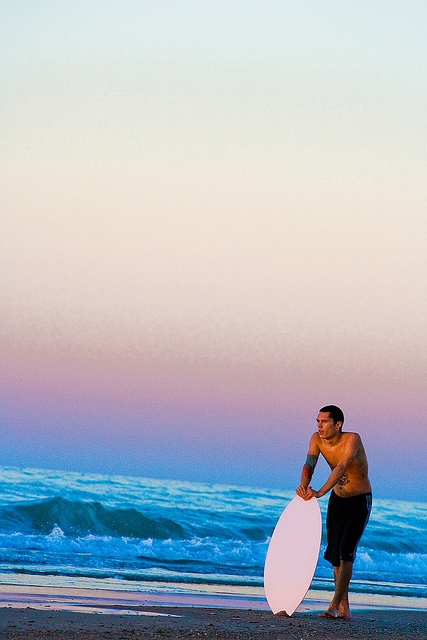Describe the objects in this image and their specific colors. I can see people in lightgray, black, maroon, brown, and red tones and surfboard in lightgray, pink, and darkgray tones in this image. 